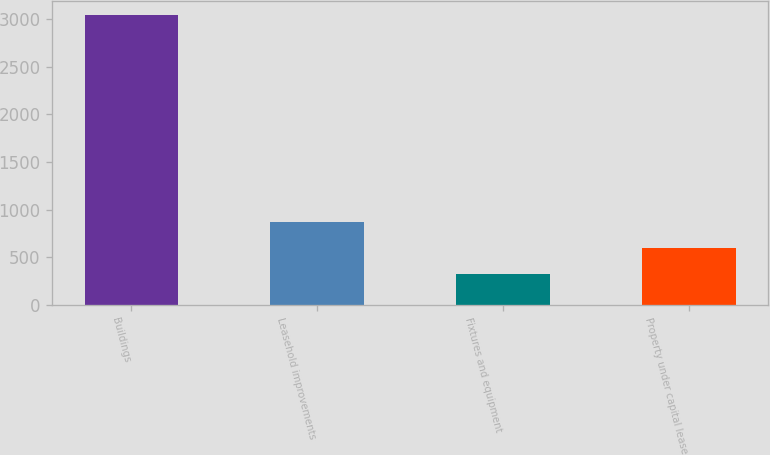Convert chart to OTSL. <chart><loc_0><loc_0><loc_500><loc_500><bar_chart><fcel>Buildings<fcel>Leasehold improvements<fcel>Fixtures and equipment<fcel>Property under capital lease<nl><fcel>3040<fcel>864<fcel>320<fcel>592<nl></chart> 